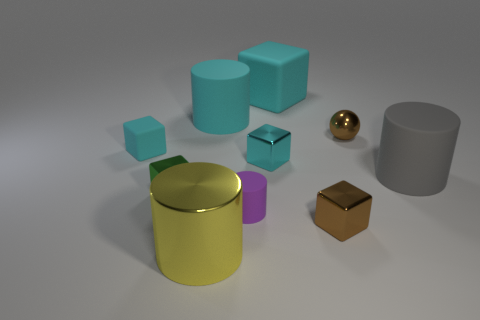How many cyan cubes must be subtracted to get 1 cyan cubes? 2 Subtract all brown balls. How many cyan blocks are left? 3 Subtract all brown shiny cubes. How many cubes are left? 4 Subtract 3 cubes. How many cubes are left? 2 Subtract all gray cylinders. How many cylinders are left? 3 Subtract all brown cylinders. Subtract all green blocks. How many cylinders are left? 4 Subtract all cylinders. How many objects are left? 6 Subtract all big matte cubes. Subtract all red metallic objects. How many objects are left? 9 Add 9 small cyan matte blocks. How many small cyan matte blocks are left? 10 Add 7 large yellow cylinders. How many large yellow cylinders exist? 8 